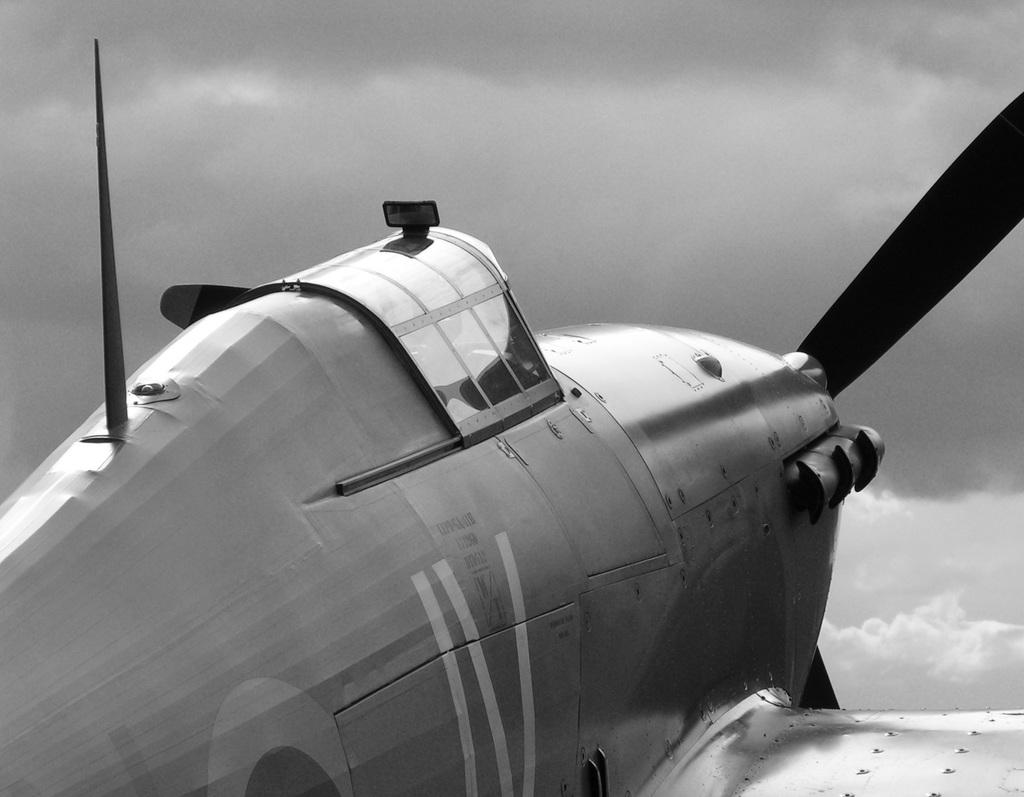What is the main subject of the image? There is an aeroplane in the center of the image. What can be seen in the background of the image? There are clouds and the sky visible in the background of the image. How many beds are visible in the image? There are no beds present in the image; it features an aeroplane and clouds in the sky. 